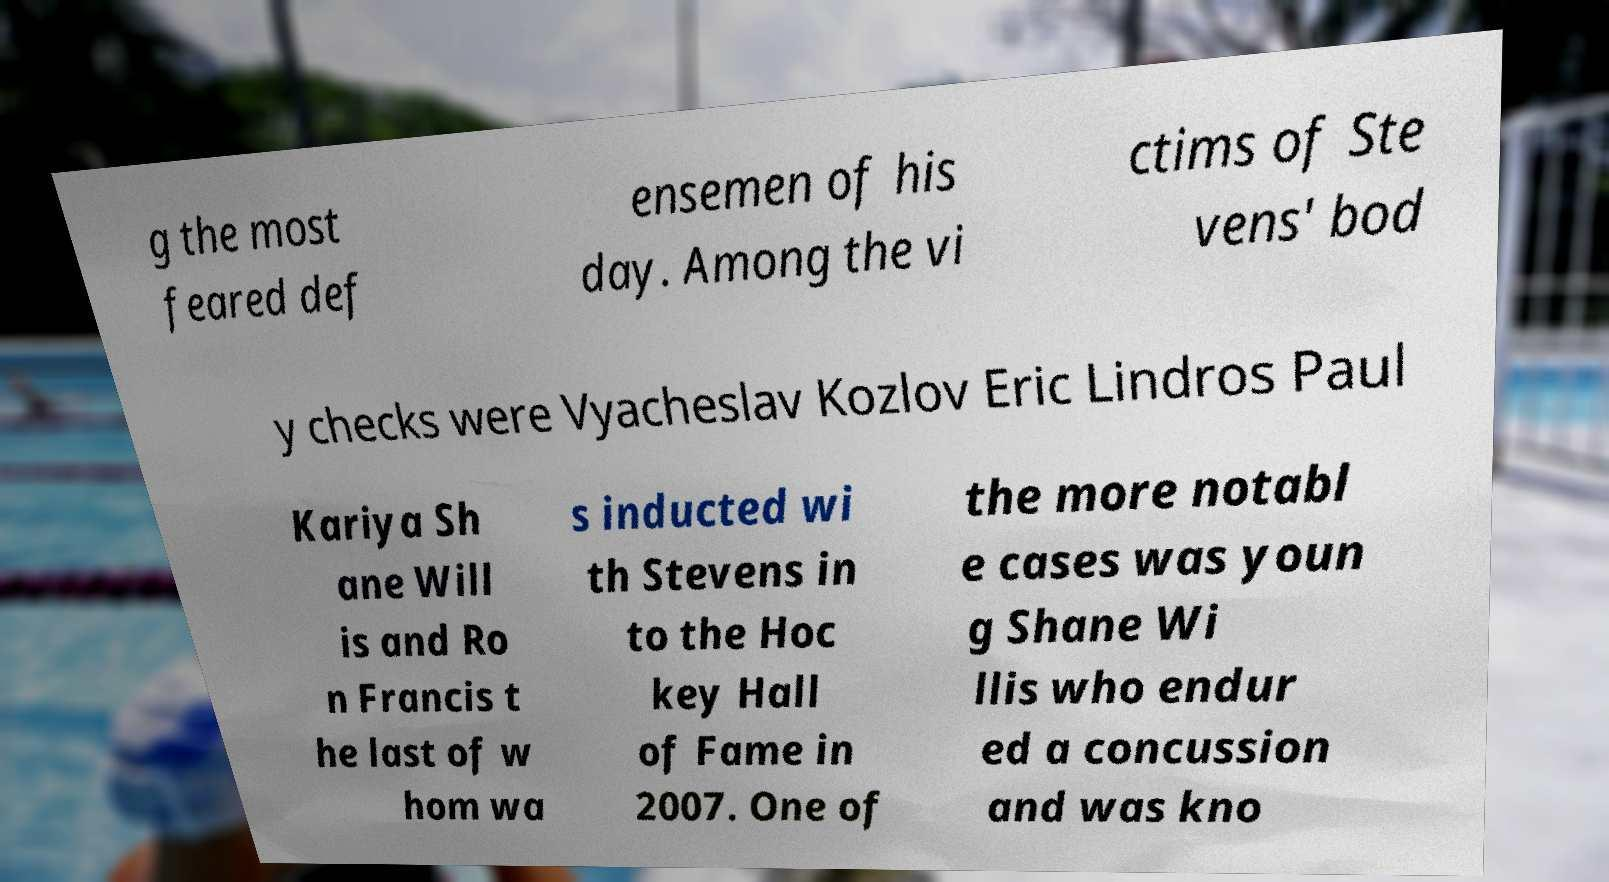Could you extract and type out the text from this image? g the most feared def ensemen of his day. Among the vi ctims of Ste vens' bod y checks were Vyacheslav Kozlov Eric Lindros Paul Kariya Sh ane Will is and Ro n Francis t he last of w hom wa s inducted wi th Stevens in to the Hoc key Hall of Fame in 2007. One of the more notabl e cases was youn g Shane Wi llis who endur ed a concussion and was kno 